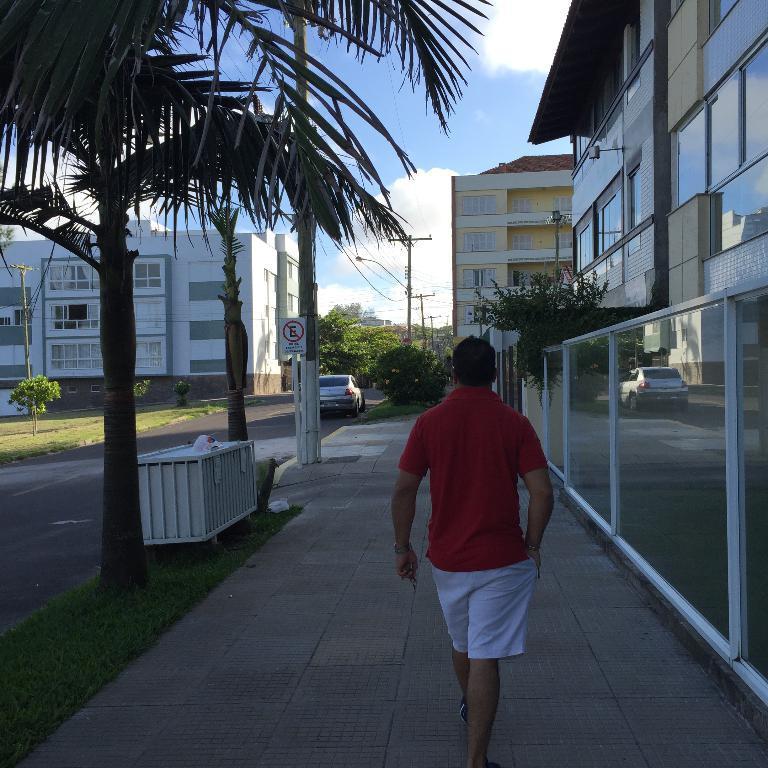Describe this image in one or two sentences. In this image I can see few buildings, windows, trees, current poles, wires, light poles, glass fencing, white box, vehicle, sign boards and pole. The sky is in blue and white color and one person is walking. 